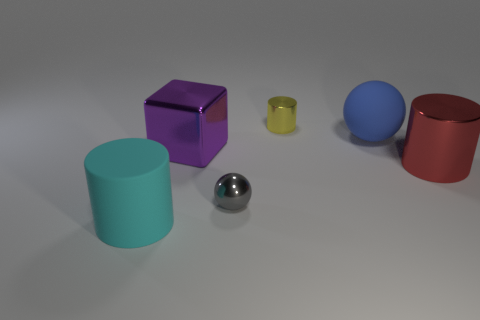Add 2 big blocks. How many objects exist? 8 Subtract all cubes. How many objects are left? 5 Add 5 large cubes. How many large cubes exist? 6 Subtract 0 brown spheres. How many objects are left? 6 Subtract all big blue objects. Subtract all big rubber cylinders. How many objects are left? 4 Add 2 cyan rubber objects. How many cyan rubber objects are left? 3 